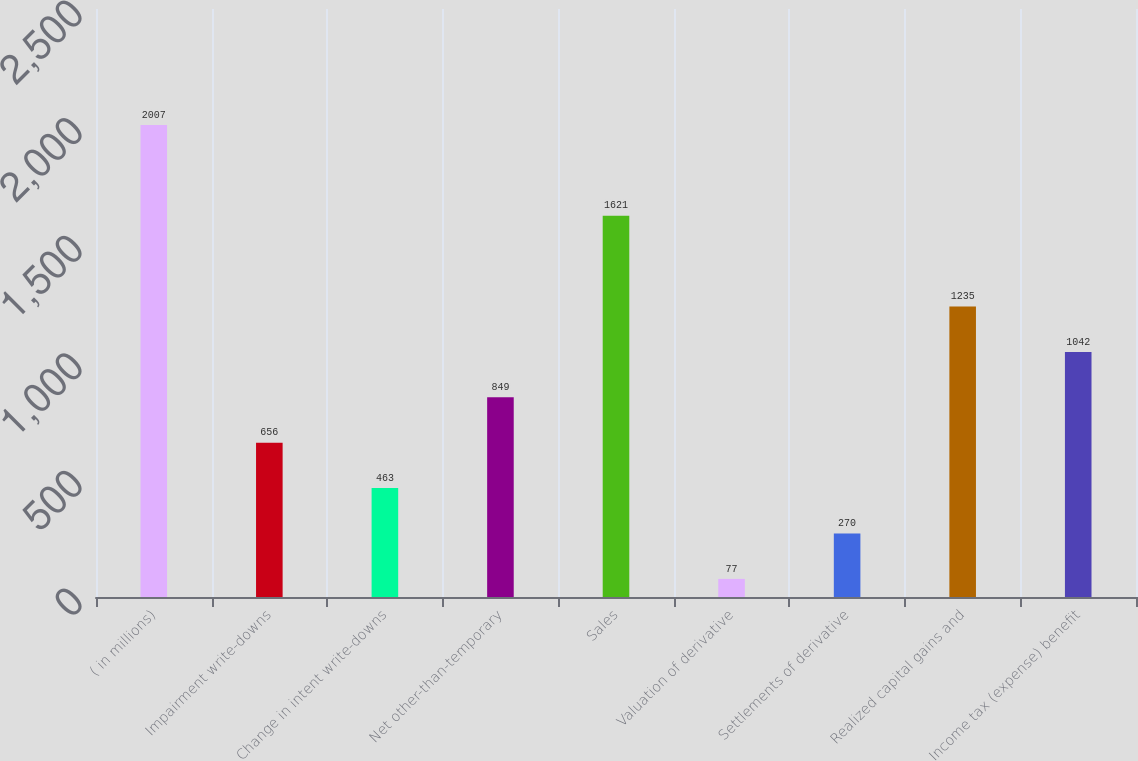Convert chart. <chart><loc_0><loc_0><loc_500><loc_500><bar_chart><fcel>( in millions)<fcel>Impairment write-downs<fcel>Change in intent write-downs<fcel>Net other-than-temporary<fcel>Sales<fcel>Valuation of derivative<fcel>Settlements of derivative<fcel>Realized capital gains and<fcel>Income tax (expense) benefit<nl><fcel>2007<fcel>656<fcel>463<fcel>849<fcel>1621<fcel>77<fcel>270<fcel>1235<fcel>1042<nl></chart> 